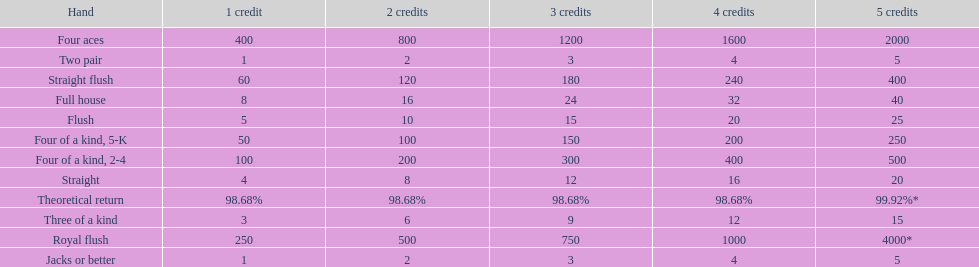The number of credits returned for a one credit bet on a royal flush are. 250. 